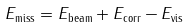Convert formula to latex. <formula><loc_0><loc_0><loc_500><loc_500>E _ { \text {miss} } = E _ { \text {beam} } + E _ { \text {corr} } - E _ { \text {vis} }</formula> 